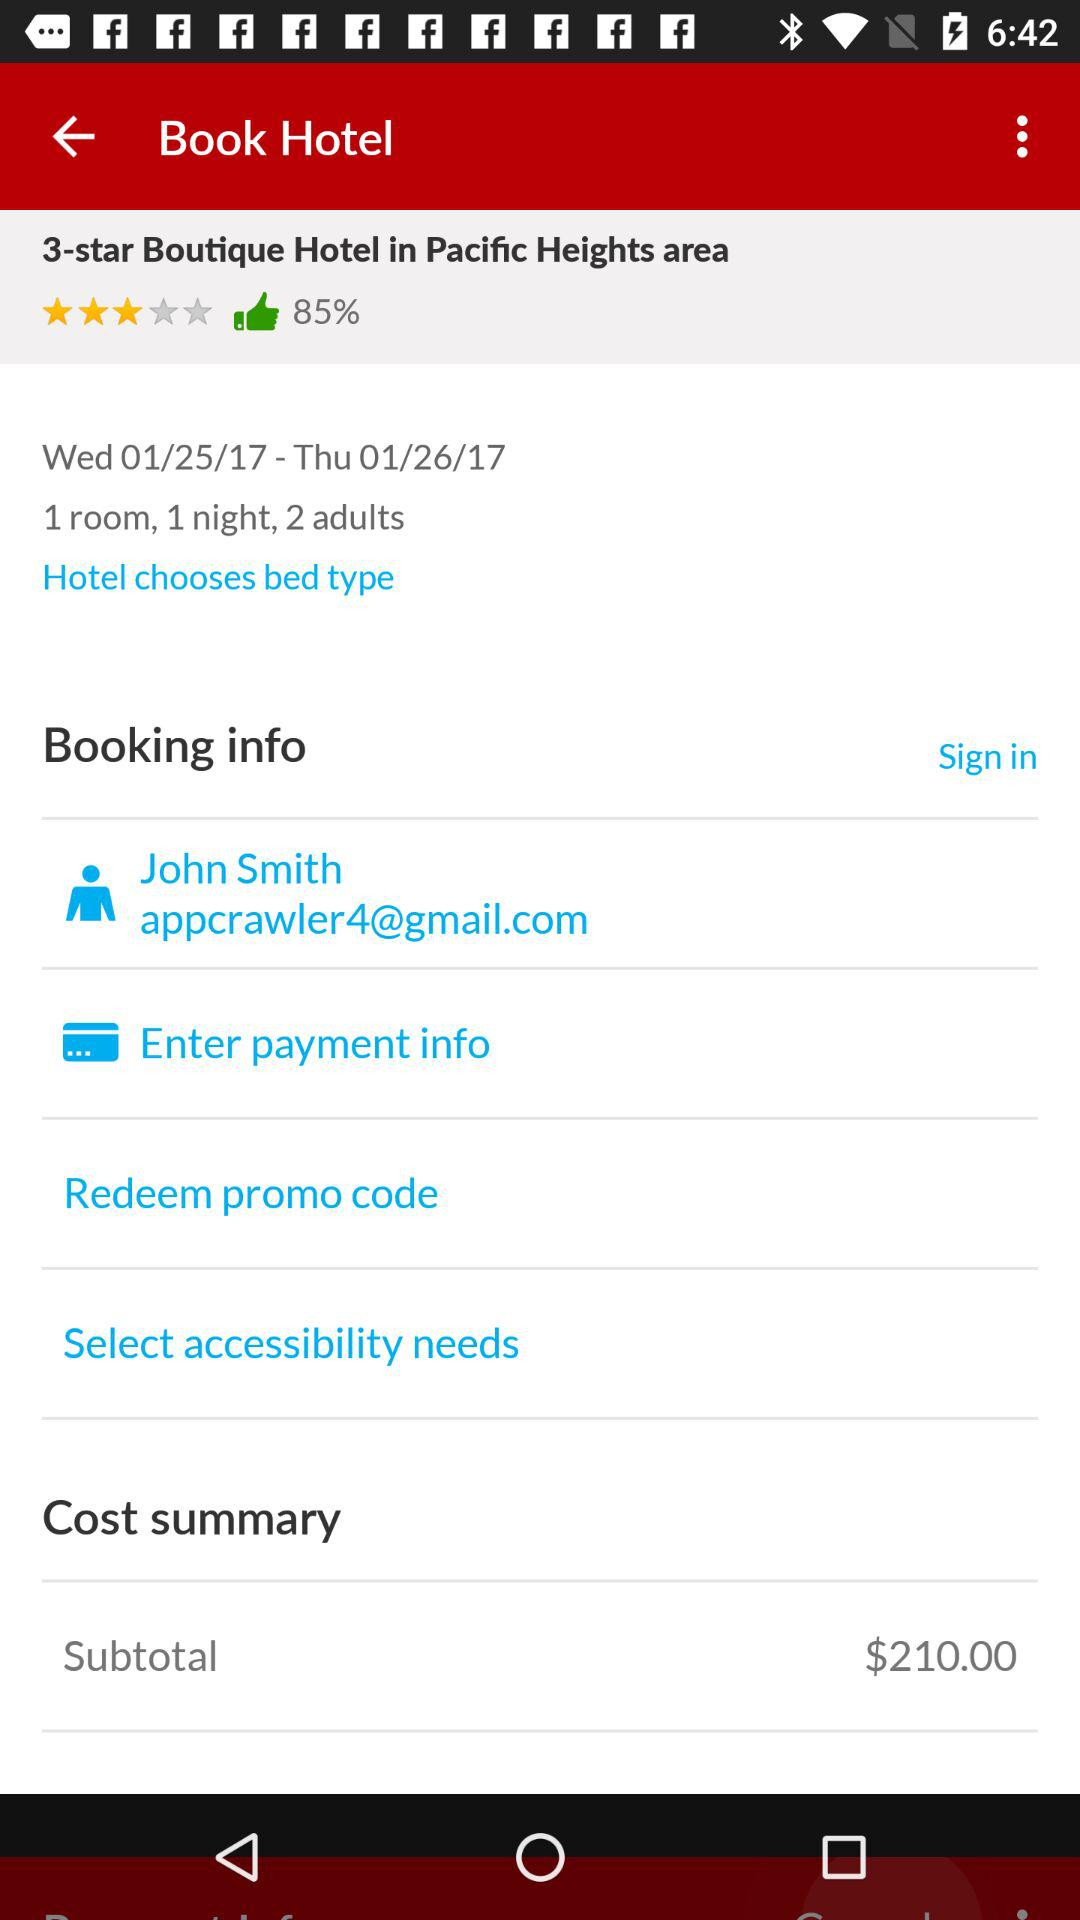How much is this booking?
Answer the question using a single word or phrase. $210.00 